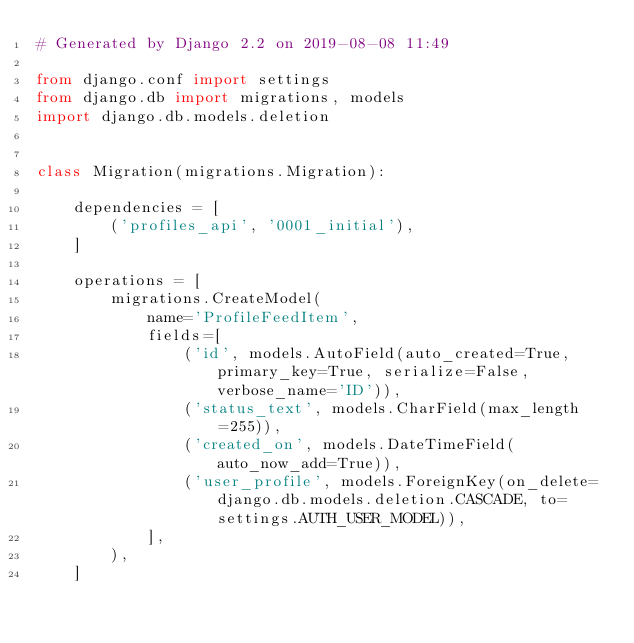Convert code to text. <code><loc_0><loc_0><loc_500><loc_500><_Python_># Generated by Django 2.2 on 2019-08-08 11:49

from django.conf import settings
from django.db import migrations, models
import django.db.models.deletion


class Migration(migrations.Migration):

    dependencies = [
        ('profiles_api', '0001_initial'),
    ]

    operations = [
        migrations.CreateModel(
            name='ProfileFeedItem',
            fields=[
                ('id', models.AutoField(auto_created=True, primary_key=True, serialize=False, verbose_name='ID')),
                ('status_text', models.CharField(max_length=255)),
                ('created_on', models.DateTimeField(auto_now_add=True)),
                ('user_profile', models.ForeignKey(on_delete=django.db.models.deletion.CASCADE, to=settings.AUTH_USER_MODEL)),
            ],
        ),
    ]
</code> 